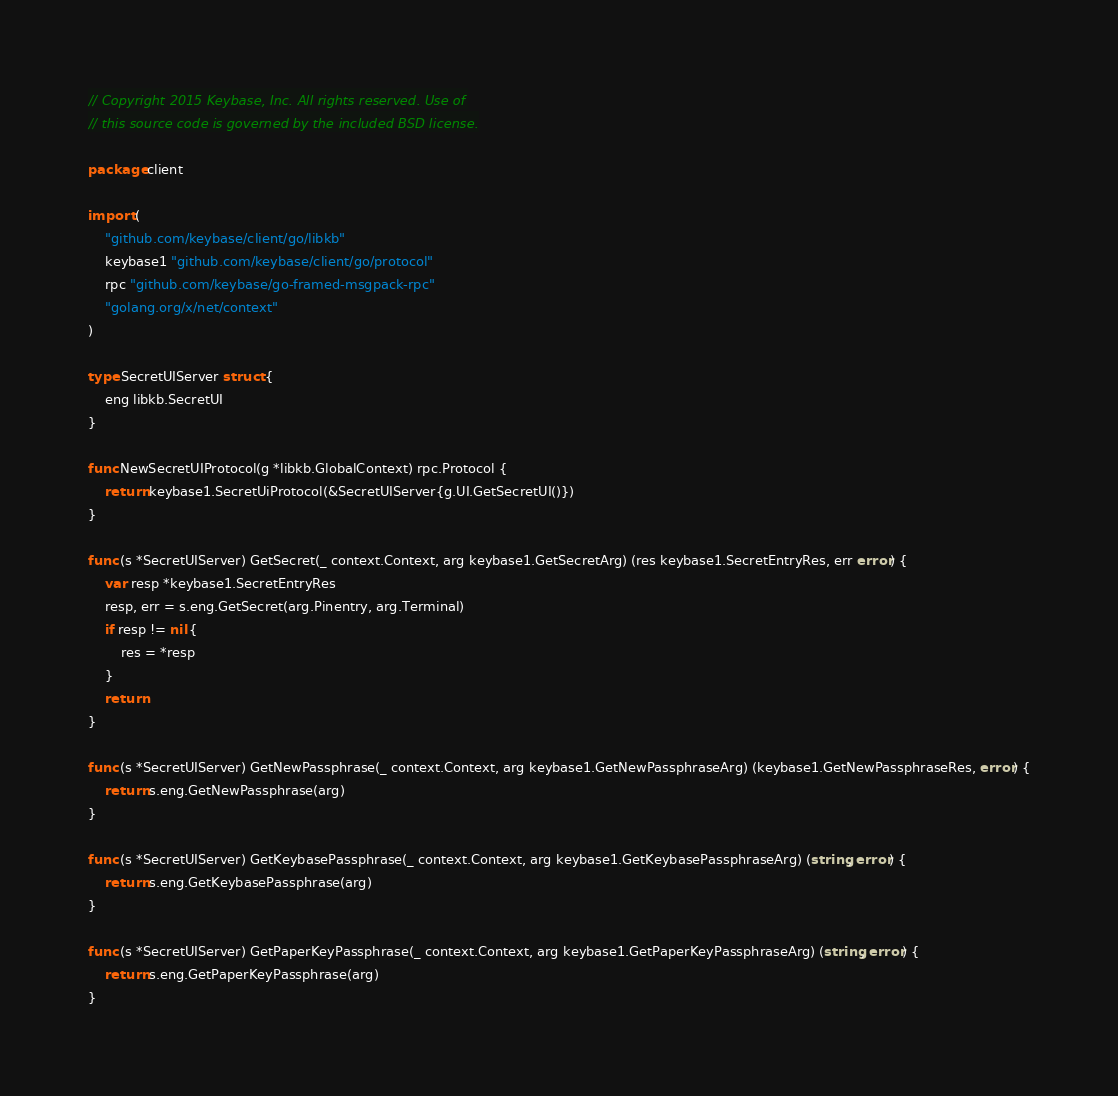Convert code to text. <code><loc_0><loc_0><loc_500><loc_500><_Go_>// Copyright 2015 Keybase, Inc. All rights reserved. Use of
// this source code is governed by the included BSD license.

package client

import (
	"github.com/keybase/client/go/libkb"
	keybase1 "github.com/keybase/client/go/protocol"
	rpc "github.com/keybase/go-framed-msgpack-rpc"
	"golang.org/x/net/context"
)

type SecretUIServer struct {
	eng libkb.SecretUI
}

func NewSecretUIProtocol(g *libkb.GlobalContext) rpc.Protocol {
	return keybase1.SecretUiProtocol(&SecretUIServer{g.UI.GetSecretUI()})
}

func (s *SecretUIServer) GetSecret(_ context.Context, arg keybase1.GetSecretArg) (res keybase1.SecretEntryRes, err error) {
	var resp *keybase1.SecretEntryRes
	resp, err = s.eng.GetSecret(arg.Pinentry, arg.Terminal)
	if resp != nil {
		res = *resp
	}
	return
}

func (s *SecretUIServer) GetNewPassphrase(_ context.Context, arg keybase1.GetNewPassphraseArg) (keybase1.GetNewPassphraseRes, error) {
	return s.eng.GetNewPassphrase(arg)
}

func (s *SecretUIServer) GetKeybasePassphrase(_ context.Context, arg keybase1.GetKeybasePassphraseArg) (string, error) {
	return s.eng.GetKeybasePassphrase(arg)
}

func (s *SecretUIServer) GetPaperKeyPassphrase(_ context.Context, arg keybase1.GetPaperKeyPassphraseArg) (string, error) {
	return s.eng.GetPaperKeyPassphrase(arg)
}
</code> 